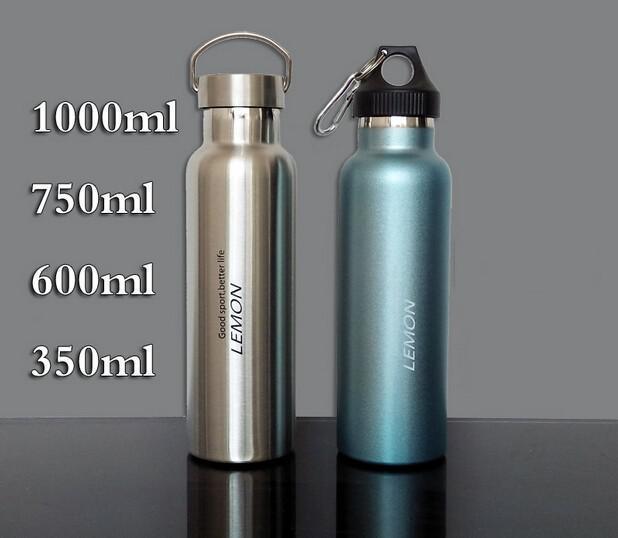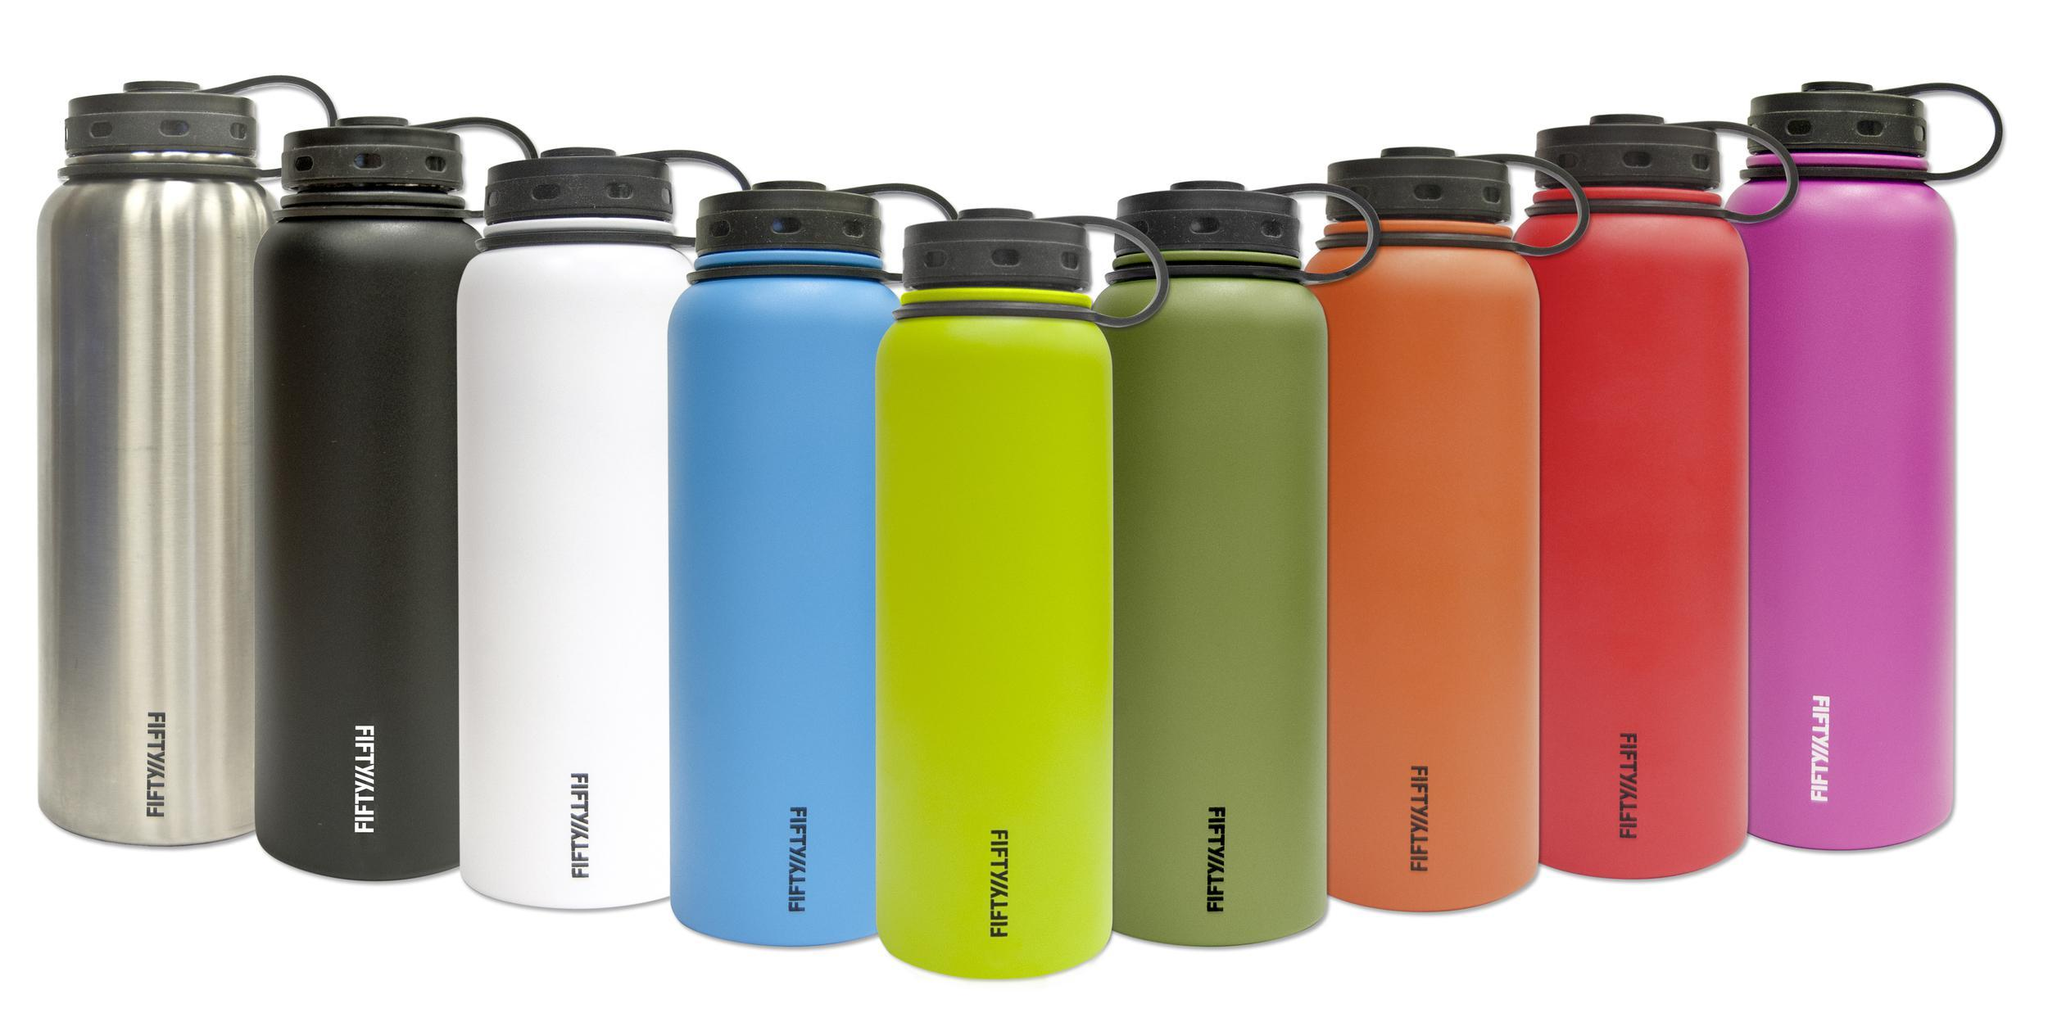The first image is the image on the left, the second image is the image on the right. Considering the images on both sides, is "The bottle in the left image that is closest to the left edge is chrome." valid? Answer yes or no. Yes. The first image is the image on the left, the second image is the image on the right. Assess this claim about the two images: "The left hand image contains a solo water bottle, while the left hand image contains a row or varying colored water bottles.". Correct or not? Answer yes or no. No. 